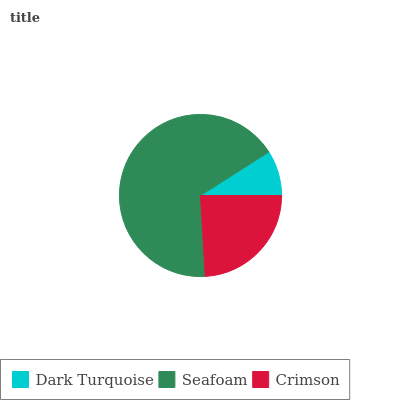Is Dark Turquoise the minimum?
Answer yes or no. Yes. Is Seafoam the maximum?
Answer yes or no. Yes. Is Crimson the minimum?
Answer yes or no. No. Is Crimson the maximum?
Answer yes or no. No. Is Seafoam greater than Crimson?
Answer yes or no. Yes. Is Crimson less than Seafoam?
Answer yes or no. Yes. Is Crimson greater than Seafoam?
Answer yes or no. No. Is Seafoam less than Crimson?
Answer yes or no. No. Is Crimson the high median?
Answer yes or no. Yes. Is Crimson the low median?
Answer yes or no. Yes. Is Dark Turquoise the high median?
Answer yes or no. No. Is Dark Turquoise the low median?
Answer yes or no. No. 